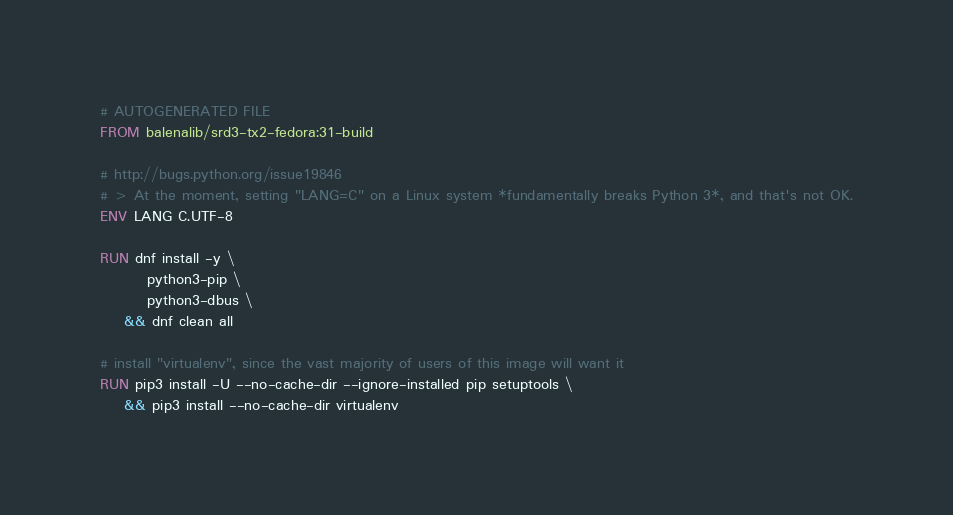<code> <loc_0><loc_0><loc_500><loc_500><_Dockerfile_># AUTOGENERATED FILE
FROM balenalib/srd3-tx2-fedora:31-build

# http://bugs.python.org/issue19846
# > At the moment, setting "LANG=C" on a Linux system *fundamentally breaks Python 3*, and that's not OK.
ENV LANG C.UTF-8

RUN dnf install -y \
		python3-pip \
		python3-dbus \
	&& dnf clean all

# install "virtualenv", since the vast majority of users of this image will want it
RUN pip3 install -U --no-cache-dir --ignore-installed pip setuptools \
	&& pip3 install --no-cache-dir virtualenv
</code> 